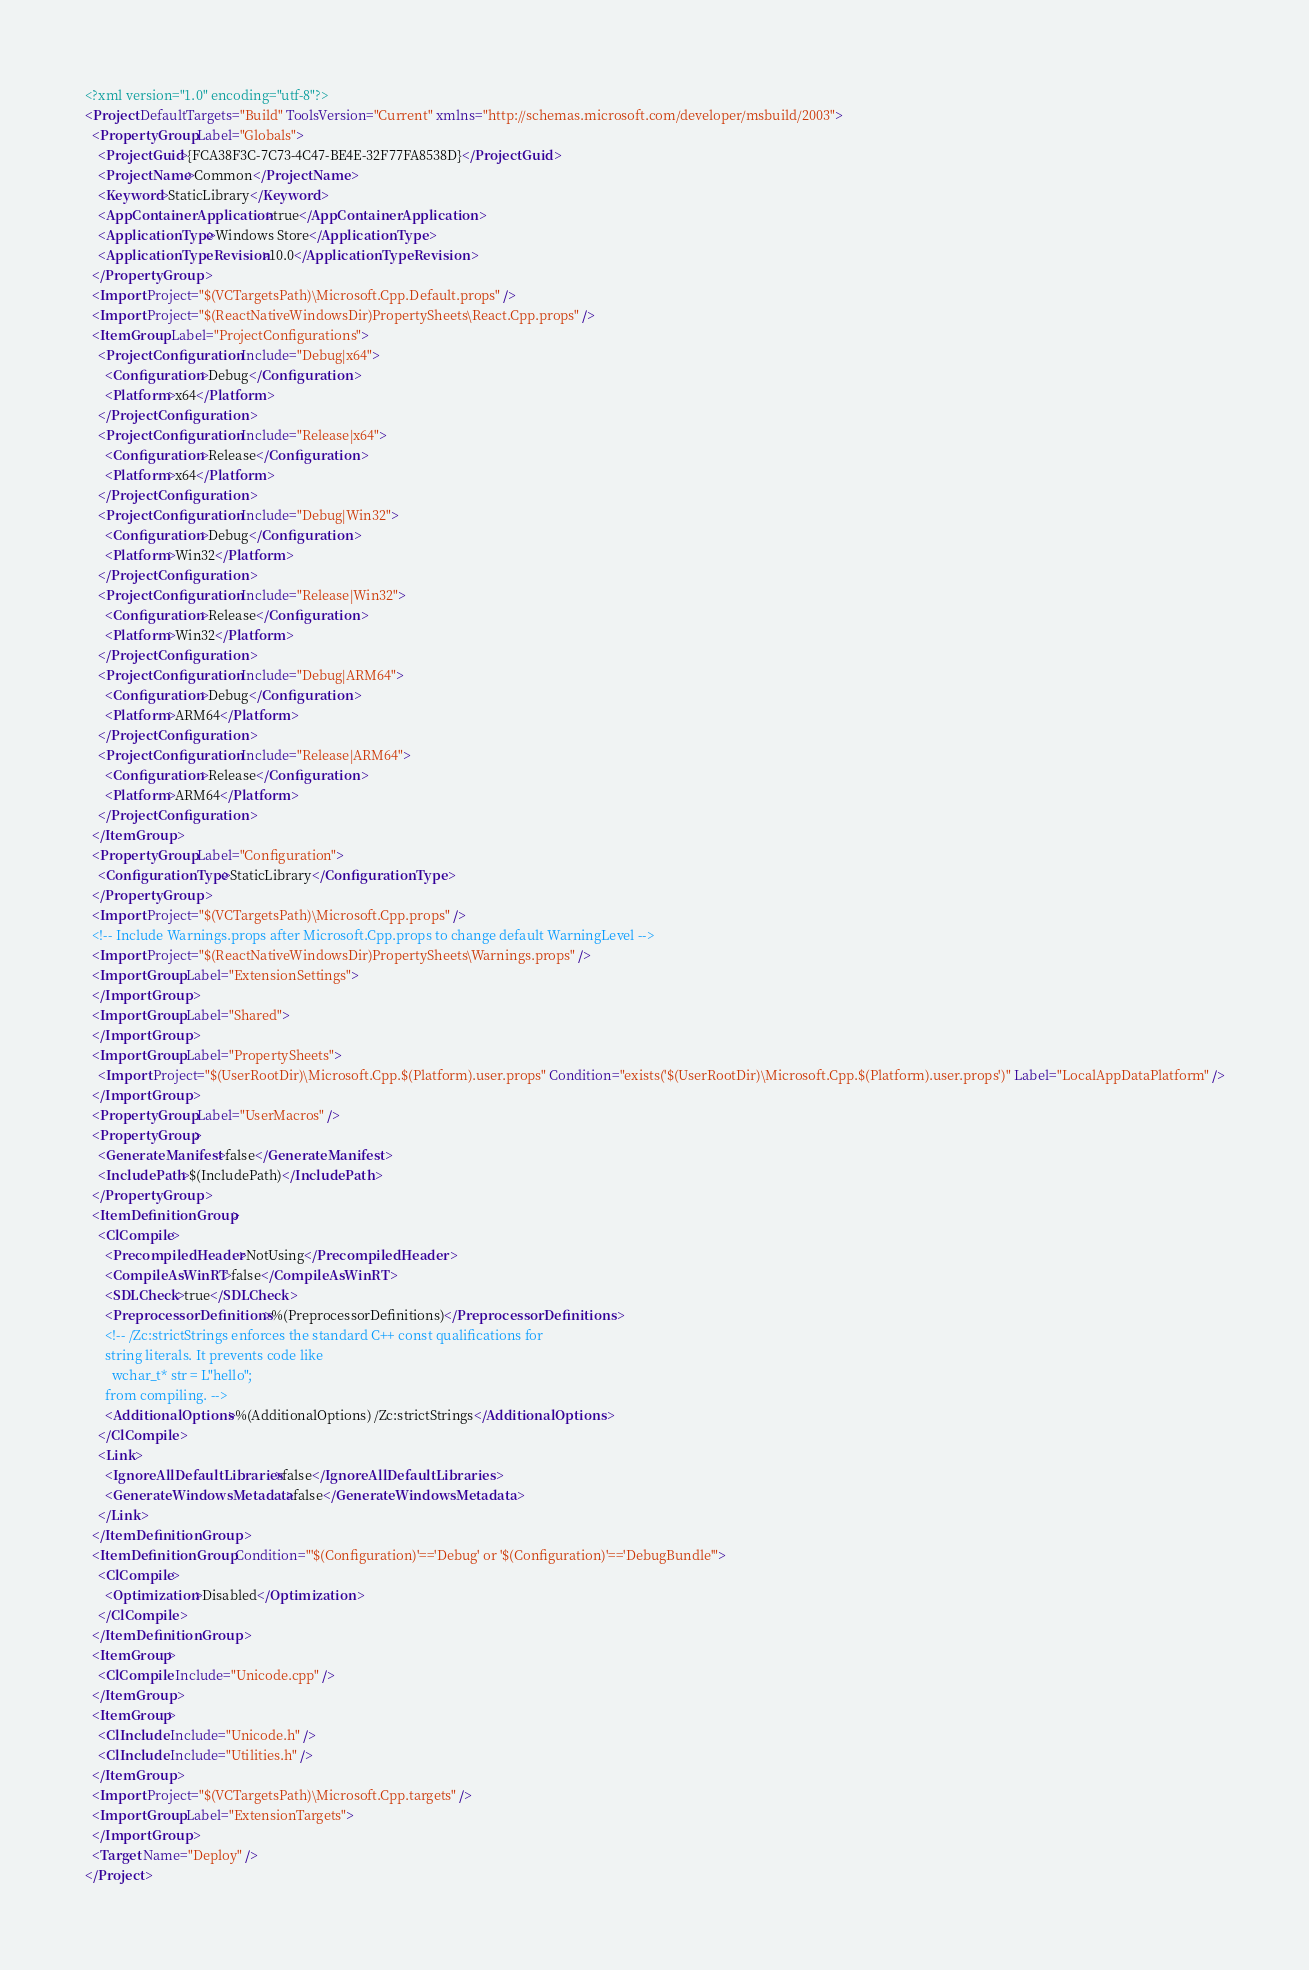Convert code to text. <code><loc_0><loc_0><loc_500><loc_500><_XML_><?xml version="1.0" encoding="utf-8"?>
<Project DefaultTargets="Build" ToolsVersion="Current" xmlns="http://schemas.microsoft.com/developer/msbuild/2003">
  <PropertyGroup Label="Globals">
    <ProjectGuid>{FCA38F3C-7C73-4C47-BE4E-32F77FA8538D}</ProjectGuid>
    <ProjectName>Common</ProjectName>
    <Keyword>StaticLibrary</Keyword>
    <AppContainerApplication>true</AppContainerApplication>
    <ApplicationType>Windows Store</ApplicationType>
    <ApplicationTypeRevision>10.0</ApplicationTypeRevision>
  </PropertyGroup>
  <Import Project="$(VCTargetsPath)\Microsoft.Cpp.Default.props" />
  <Import Project="$(ReactNativeWindowsDir)PropertySheets\React.Cpp.props" />
  <ItemGroup Label="ProjectConfigurations">
    <ProjectConfiguration Include="Debug|x64">
      <Configuration>Debug</Configuration>
      <Platform>x64</Platform>
    </ProjectConfiguration>
    <ProjectConfiguration Include="Release|x64">
      <Configuration>Release</Configuration>
      <Platform>x64</Platform>
    </ProjectConfiguration>
    <ProjectConfiguration Include="Debug|Win32">
      <Configuration>Debug</Configuration>
      <Platform>Win32</Platform>
    </ProjectConfiguration>
    <ProjectConfiguration Include="Release|Win32">
      <Configuration>Release</Configuration>
      <Platform>Win32</Platform>
    </ProjectConfiguration>
    <ProjectConfiguration Include="Debug|ARM64">
      <Configuration>Debug</Configuration>
      <Platform>ARM64</Platform>
    </ProjectConfiguration>
    <ProjectConfiguration Include="Release|ARM64">
      <Configuration>Release</Configuration>
      <Platform>ARM64</Platform>
    </ProjectConfiguration>
  </ItemGroup>
  <PropertyGroup Label="Configuration">
    <ConfigurationType>StaticLibrary</ConfigurationType>
  </PropertyGroup>
  <Import Project="$(VCTargetsPath)\Microsoft.Cpp.props" />
  <!-- Include Warnings.props after Microsoft.Cpp.props to change default WarningLevel -->
  <Import Project="$(ReactNativeWindowsDir)PropertySheets\Warnings.props" />
  <ImportGroup Label="ExtensionSettings">
  </ImportGroup>
  <ImportGroup Label="Shared">
  </ImportGroup>
  <ImportGroup Label="PropertySheets">
    <Import Project="$(UserRootDir)\Microsoft.Cpp.$(Platform).user.props" Condition="exists('$(UserRootDir)\Microsoft.Cpp.$(Platform).user.props')" Label="LocalAppDataPlatform" />
  </ImportGroup>
  <PropertyGroup Label="UserMacros" />
  <PropertyGroup>
    <GenerateManifest>false</GenerateManifest>
    <IncludePath>$(IncludePath)</IncludePath>
  </PropertyGroup>
  <ItemDefinitionGroup>
    <ClCompile>
      <PrecompiledHeader>NotUsing</PrecompiledHeader>
      <CompileAsWinRT>false</CompileAsWinRT>
      <SDLCheck>true</SDLCheck>
      <PreprocessorDefinitions>%(PreprocessorDefinitions)</PreprocessorDefinitions>
      <!-- /Zc:strictStrings enforces the standard C++ const qualifications for
      string literals. It prevents code like
        wchar_t* str = L"hello";
      from compiling. -->
      <AdditionalOptions>%(AdditionalOptions) /Zc:strictStrings</AdditionalOptions>
    </ClCompile>
    <Link>
      <IgnoreAllDefaultLibraries>false</IgnoreAllDefaultLibraries>
      <GenerateWindowsMetadata>false</GenerateWindowsMetadata>
    </Link>
  </ItemDefinitionGroup>
  <ItemDefinitionGroup Condition="'$(Configuration)'=='Debug' or '$(Configuration)'=='DebugBundle'">
    <ClCompile>
      <Optimization>Disabled</Optimization>
    </ClCompile>
  </ItemDefinitionGroup>
  <ItemGroup>
    <ClCompile Include="Unicode.cpp" />
  </ItemGroup>
  <ItemGroup>
    <ClInclude Include="Unicode.h" />
    <ClInclude Include="Utilities.h" />
  </ItemGroup>
  <Import Project="$(VCTargetsPath)\Microsoft.Cpp.targets" />
  <ImportGroup Label="ExtensionTargets">
  </ImportGroup>
  <Target Name="Deploy" />
</Project></code> 